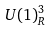Convert formula to latex. <formula><loc_0><loc_0><loc_500><loc_500>U ( 1 ) _ { R } ^ { 3 }</formula> 